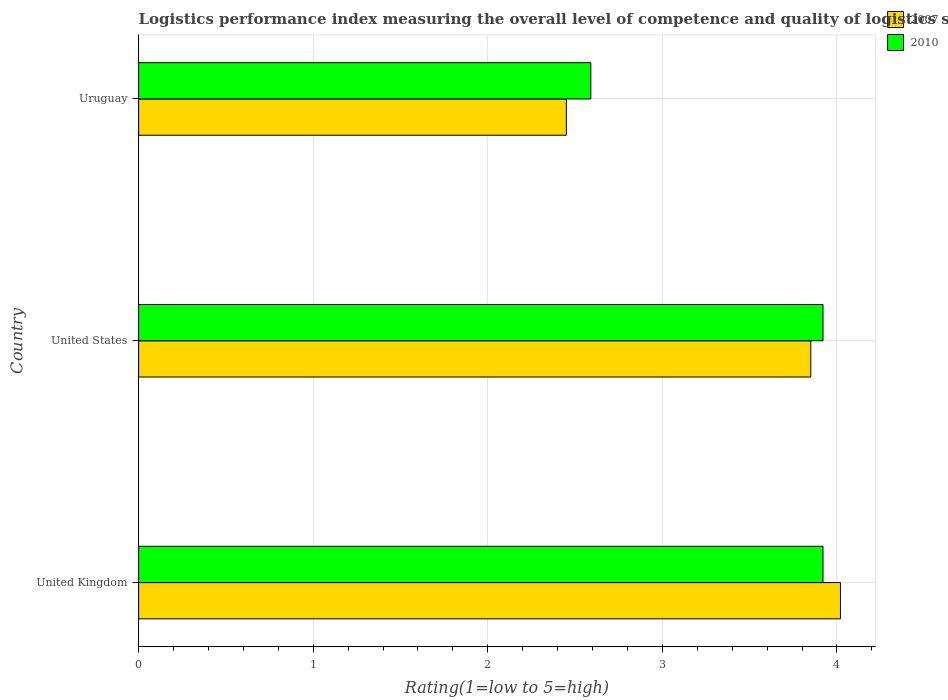How many groups of bars are there?
Offer a terse response. 3. Are the number of bars per tick equal to the number of legend labels?
Keep it short and to the point. Yes. How many bars are there on the 3rd tick from the bottom?
Keep it short and to the point. 2. In how many cases, is the number of bars for a given country not equal to the number of legend labels?
Offer a very short reply. 0. What is the Logistic performance index in 2010 in United States?
Make the answer very short. 3.92. Across all countries, what is the maximum Logistic performance index in 2010?
Your answer should be compact. 3.92. Across all countries, what is the minimum Logistic performance index in 2007?
Offer a very short reply. 2.45. In which country was the Logistic performance index in 2010 minimum?
Your answer should be compact. Uruguay. What is the total Logistic performance index in 2007 in the graph?
Offer a very short reply. 10.32. What is the difference between the Logistic performance index in 2007 in United Kingdom and that in United States?
Make the answer very short. 0.17. What is the difference between the Logistic performance index in 2007 in Uruguay and the Logistic performance index in 2010 in United Kingdom?
Your answer should be very brief. -1.47. What is the average Logistic performance index in 2010 per country?
Your answer should be compact. 3.48. What is the difference between the Logistic performance index in 2010 and Logistic performance index in 2007 in United States?
Ensure brevity in your answer.  0.07. In how many countries, is the Logistic performance index in 2010 greater than 1.2 ?
Your answer should be compact. 3. What is the ratio of the Logistic performance index in 2007 in United Kingdom to that in Uruguay?
Offer a very short reply. 1.64. Is the difference between the Logistic performance index in 2010 in United Kingdom and United States greater than the difference between the Logistic performance index in 2007 in United Kingdom and United States?
Offer a terse response. No. What is the difference between the highest and the second highest Logistic performance index in 2010?
Your answer should be compact. 0. What is the difference between the highest and the lowest Logistic performance index in 2007?
Your answer should be compact. 1.57. Is the sum of the Logistic performance index in 2007 in United Kingdom and Uruguay greater than the maximum Logistic performance index in 2010 across all countries?
Provide a short and direct response. Yes. Are all the bars in the graph horizontal?
Give a very brief answer. Yes. What is the difference between two consecutive major ticks on the X-axis?
Provide a short and direct response. 1. Are the values on the major ticks of X-axis written in scientific E-notation?
Make the answer very short. No. Where does the legend appear in the graph?
Ensure brevity in your answer.  Top right. How are the legend labels stacked?
Ensure brevity in your answer.  Vertical. What is the title of the graph?
Your answer should be very brief. Logistics performance index measuring the overall level of competence and quality of logistics services. Does "1992" appear as one of the legend labels in the graph?
Provide a succinct answer. No. What is the label or title of the X-axis?
Your response must be concise. Rating(1=low to 5=high). What is the label or title of the Y-axis?
Give a very brief answer. Country. What is the Rating(1=low to 5=high) of 2007 in United Kingdom?
Your answer should be very brief. 4.02. What is the Rating(1=low to 5=high) in 2010 in United Kingdom?
Provide a succinct answer. 3.92. What is the Rating(1=low to 5=high) in 2007 in United States?
Your response must be concise. 3.85. What is the Rating(1=low to 5=high) of 2010 in United States?
Your answer should be very brief. 3.92. What is the Rating(1=low to 5=high) in 2007 in Uruguay?
Your answer should be very brief. 2.45. What is the Rating(1=low to 5=high) of 2010 in Uruguay?
Provide a short and direct response. 2.59. Across all countries, what is the maximum Rating(1=low to 5=high) in 2007?
Keep it short and to the point. 4.02. Across all countries, what is the maximum Rating(1=low to 5=high) in 2010?
Your answer should be compact. 3.92. Across all countries, what is the minimum Rating(1=low to 5=high) of 2007?
Provide a short and direct response. 2.45. Across all countries, what is the minimum Rating(1=low to 5=high) in 2010?
Offer a very short reply. 2.59. What is the total Rating(1=low to 5=high) in 2007 in the graph?
Provide a short and direct response. 10.32. What is the total Rating(1=low to 5=high) of 2010 in the graph?
Make the answer very short. 10.43. What is the difference between the Rating(1=low to 5=high) of 2007 in United Kingdom and that in United States?
Ensure brevity in your answer.  0.17. What is the difference between the Rating(1=low to 5=high) in 2010 in United Kingdom and that in United States?
Offer a very short reply. 0. What is the difference between the Rating(1=low to 5=high) in 2007 in United Kingdom and that in Uruguay?
Your answer should be compact. 1.57. What is the difference between the Rating(1=low to 5=high) of 2010 in United Kingdom and that in Uruguay?
Ensure brevity in your answer.  1.33. What is the difference between the Rating(1=low to 5=high) of 2010 in United States and that in Uruguay?
Provide a short and direct response. 1.33. What is the difference between the Rating(1=low to 5=high) in 2007 in United Kingdom and the Rating(1=low to 5=high) in 2010 in Uruguay?
Keep it short and to the point. 1.43. What is the difference between the Rating(1=low to 5=high) of 2007 in United States and the Rating(1=low to 5=high) of 2010 in Uruguay?
Ensure brevity in your answer.  1.26. What is the average Rating(1=low to 5=high) in 2007 per country?
Offer a terse response. 3.44. What is the average Rating(1=low to 5=high) in 2010 per country?
Give a very brief answer. 3.48. What is the difference between the Rating(1=low to 5=high) of 2007 and Rating(1=low to 5=high) of 2010 in United Kingdom?
Offer a terse response. 0.1. What is the difference between the Rating(1=low to 5=high) in 2007 and Rating(1=low to 5=high) in 2010 in United States?
Your answer should be very brief. -0.07. What is the difference between the Rating(1=low to 5=high) of 2007 and Rating(1=low to 5=high) of 2010 in Uruguay?
Provide a short and direct response. -0.14. What is the ratio of the Rating(1=low to 5=high) of 2007 in United Kingdom to that in United States?
Ensure brevity in your answer.  1.04. What is the ratio of the Rating(1=low to 5=high) of 2010 in United Kingdom to that in United States?
Ensure brevity in your answer.  1. What is the ratio of the Rating(1=low to 5=high) of 2007 in United Kingdom to that in Uruguay?
Offer a very short reply. 1.64. What is the ratio of the Rating(1=low to 5=high) in 2010 in United Kingdom to that in Uruguay?
Ensure brevity in your answer.  1.51. What is the ratio of the Rating(1=low to 5=high) of 2007 in United States to that in Uruguay?
Offer a very short reply. 1.57. What is the ratio of the Rating(1=low to 5=high) of 2010 in United States to that in Uruguay?
Make the answer very short. 1.51. What is the difference between the highest and the second highest Rating(1=low to 5=high) in 2007?
Keep it short and to the point. 0.17. What is the difference between the highest and the second highest Rating(1=low to 5=high) in 2010?
Keep it short and to the point. 0. What is the difference between the highest and the lowest Rating(1=low to 5=high) in 2007?
Make the answer very short. 1.57. What is the difference between the highest and the lowest Rating(1=low to 5=high) in 2010?
Ensure brevity in your answer.  1.33. 